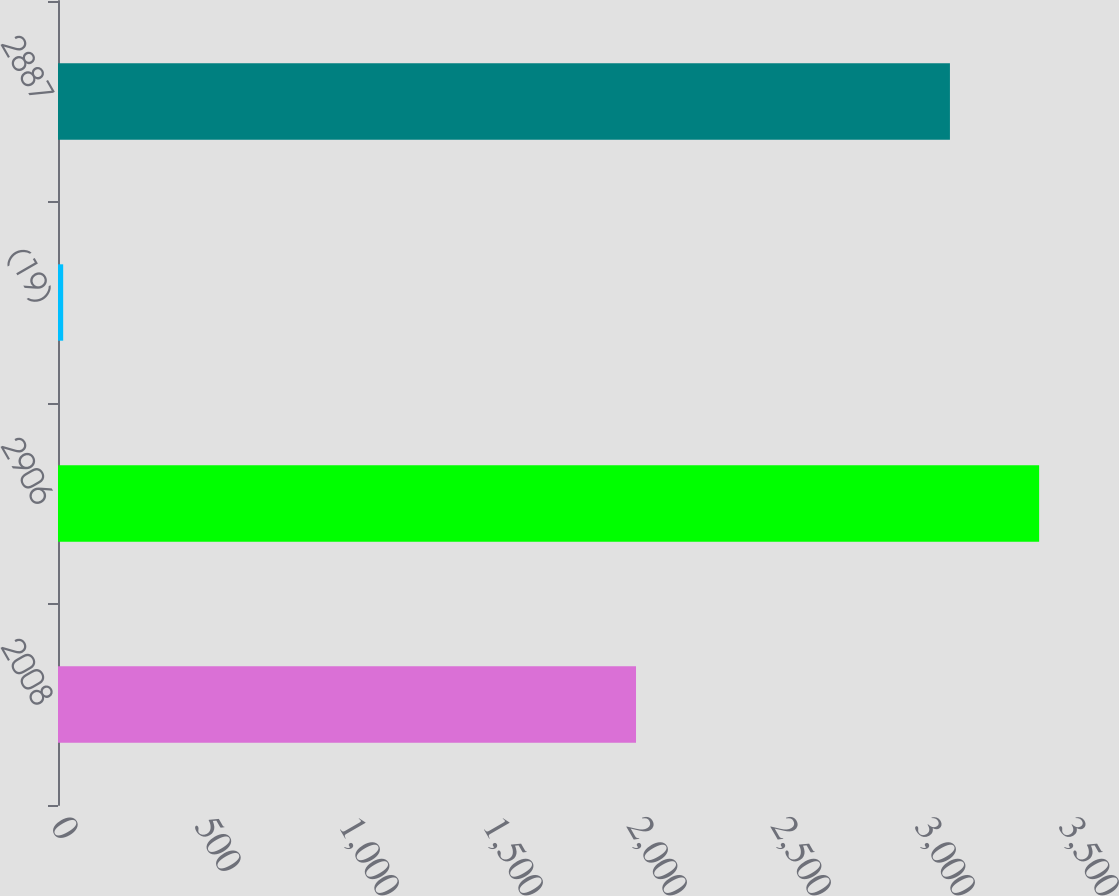Convert chart. <chart><loc_0><loc_0><loc_500><loc_500><bar_chart><fcel>2008<fcel>2906<fcel>(19)<fcel>2887<nl><fcel>2007<fcel>3406.7<fcel>18<fcel>3097<nl></chart> 